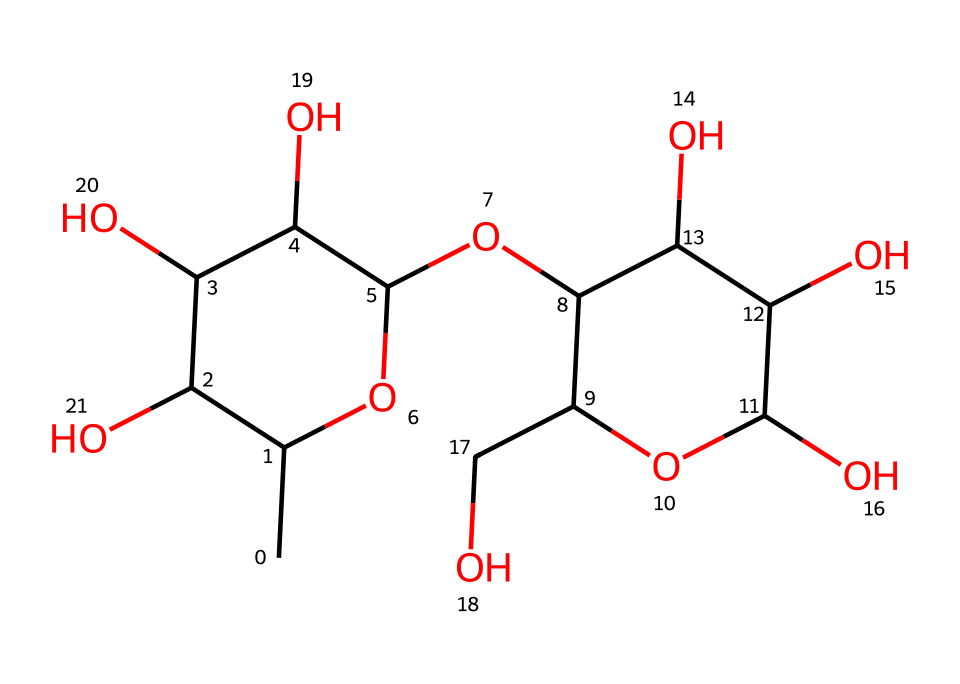What is the molecular formula of dextran based on the chemical structure? To determine the molecular formula from the structure, we count the carbon (C), hydrogen (H), and oxygen (O) atoms. In the provided SMILES, there are 20 carbon atoms, 36 hydrogen atoms, and 18 oxygen atoms. Therefore, the molecular formula is C20H36O18.
Answer: C20H36O18 How many rings are present in the dextran structure? By analyzing the structure derived from the SMILES, we identify the cyclic components. There is one ring structure that involves the carbon atoms. Thus, there is one ring in dextran.
Answer: 1 What type of carbohydrate is dextran classified as? Dextran is classified as a polysaccharide. Polysaccharides are carbohydrates made up of many sugar molecules linked together, which corresponds to the chains present in the structure.
Answer: polysaccharide Which functional group is predominant in the dextran structure? The structure includes multiple -OH groups, which indicates the presence of alcohol functional groups. The numerous hydroxyl groups are a key feature of dextran and contribute to its solubility and biological properties.
Answer: hydroxyl How does dextran help in medical treatments for cystic fibrosis? Dextran acts as a plasma volume expander or helps with hydration by retaining water due to its polysaccharide structure, which is beneficial for cystic fibrosis patients who often have thick mucus and require better hydration.
Answer: plasma volume expander 